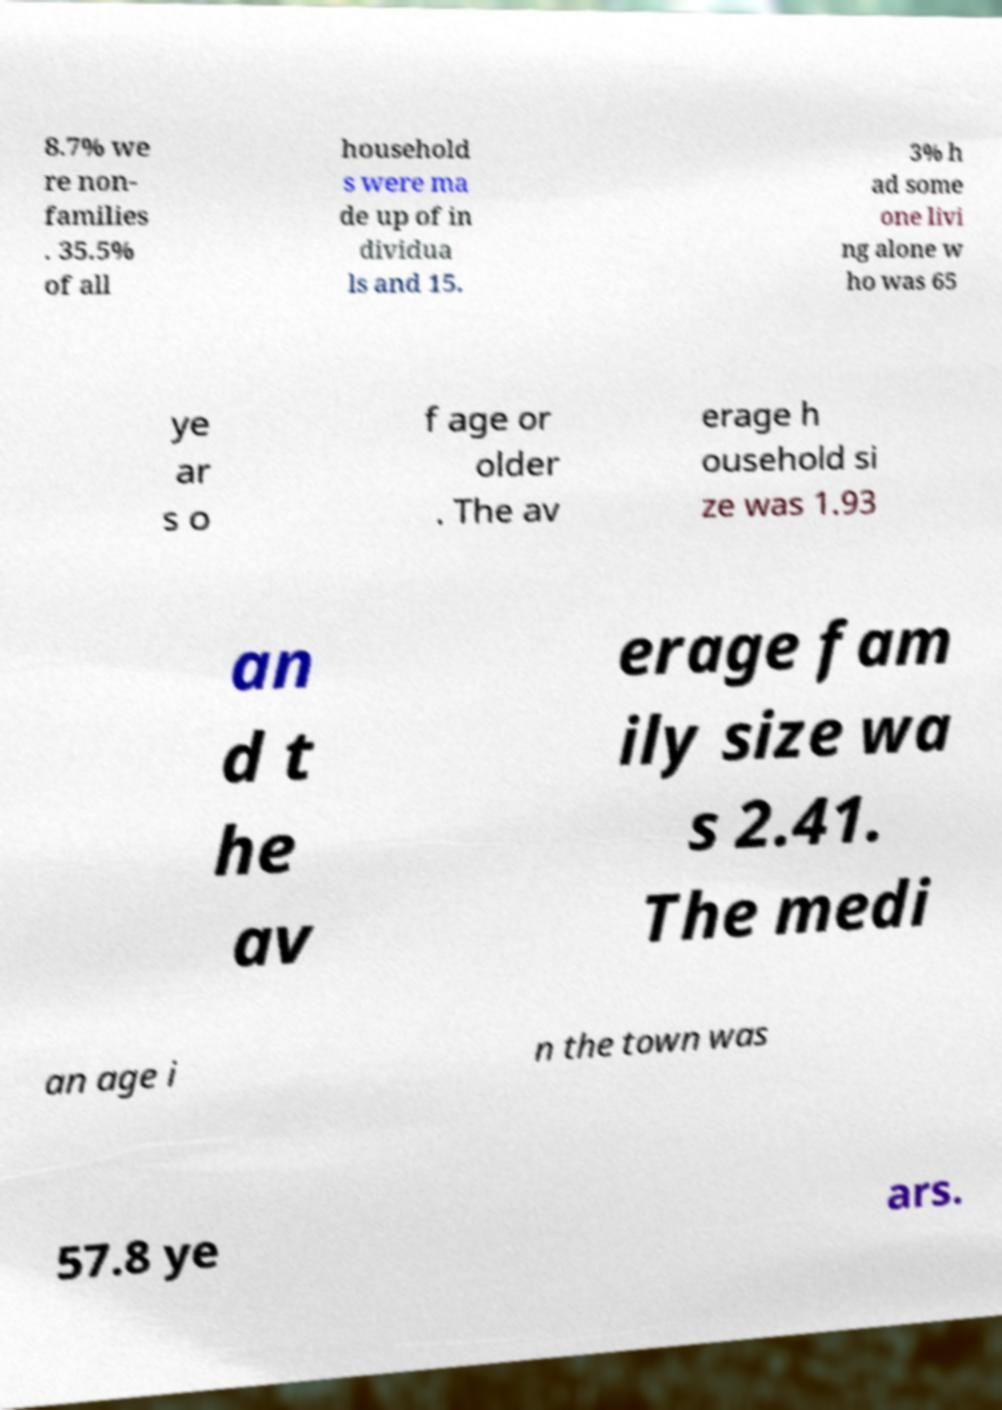Could you extract and type out the text from this image? 8.7% we re non- families . 35.5% of all household s were ma de up of in dividua ls and 15. 3% h ad some one livi ng alone w ho was 65 ye ar s o f age or older . The av erage h ousehold si ze was 1.93 an d t he av erage fam ily size wa s 2.41. The medi an age i n the town was 57.8 ye ars. 